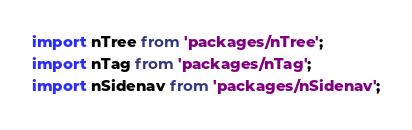Convert code to text. <code><loc_0><loc_0><loc_500><loc_500><_JavaScript_>import nTree from 'packages/nTree';
import nTag from 'packages/nTag';
import nSidenav from 'packages/nSidenav';</code> 